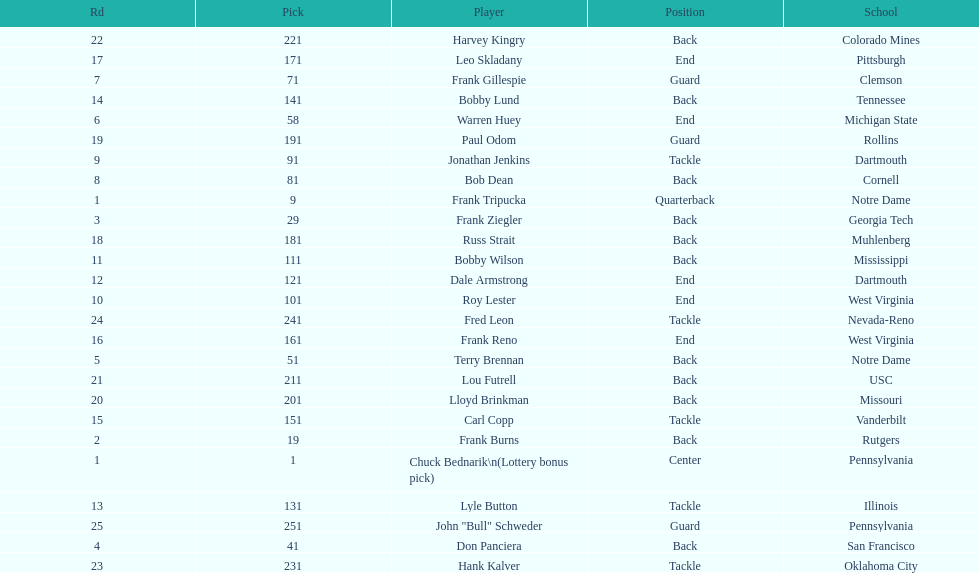Who has same position as frank gillespie? Paul Odom, John "Bull" Schweder. 